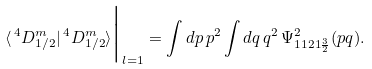Convert formula to latex. <formula><loc_0><loc_0><loc_500><loc_500>\langle \, ^ { 4 } D ^ { m } _ { 1 / 2 } | \, ^ { 4 } D ^ { m } _ { 1 / 2 } \rangle \Big | _ { l = 1 } = \int d p \, p ^ { 2 } \int d q \, q ^ { 2 } \, \Psi ^ { 2 } _ { 1 1 2 1 \frac { 3 } { 2 } } ( p q ) .</formula> 